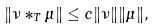Convert formula to latex. <formula><loc_0><loc_0><loc_500><loc_500>\| \nu * _ { T } \mu \| \leq c \| \nu \| \| \mu \| ,</formula> 